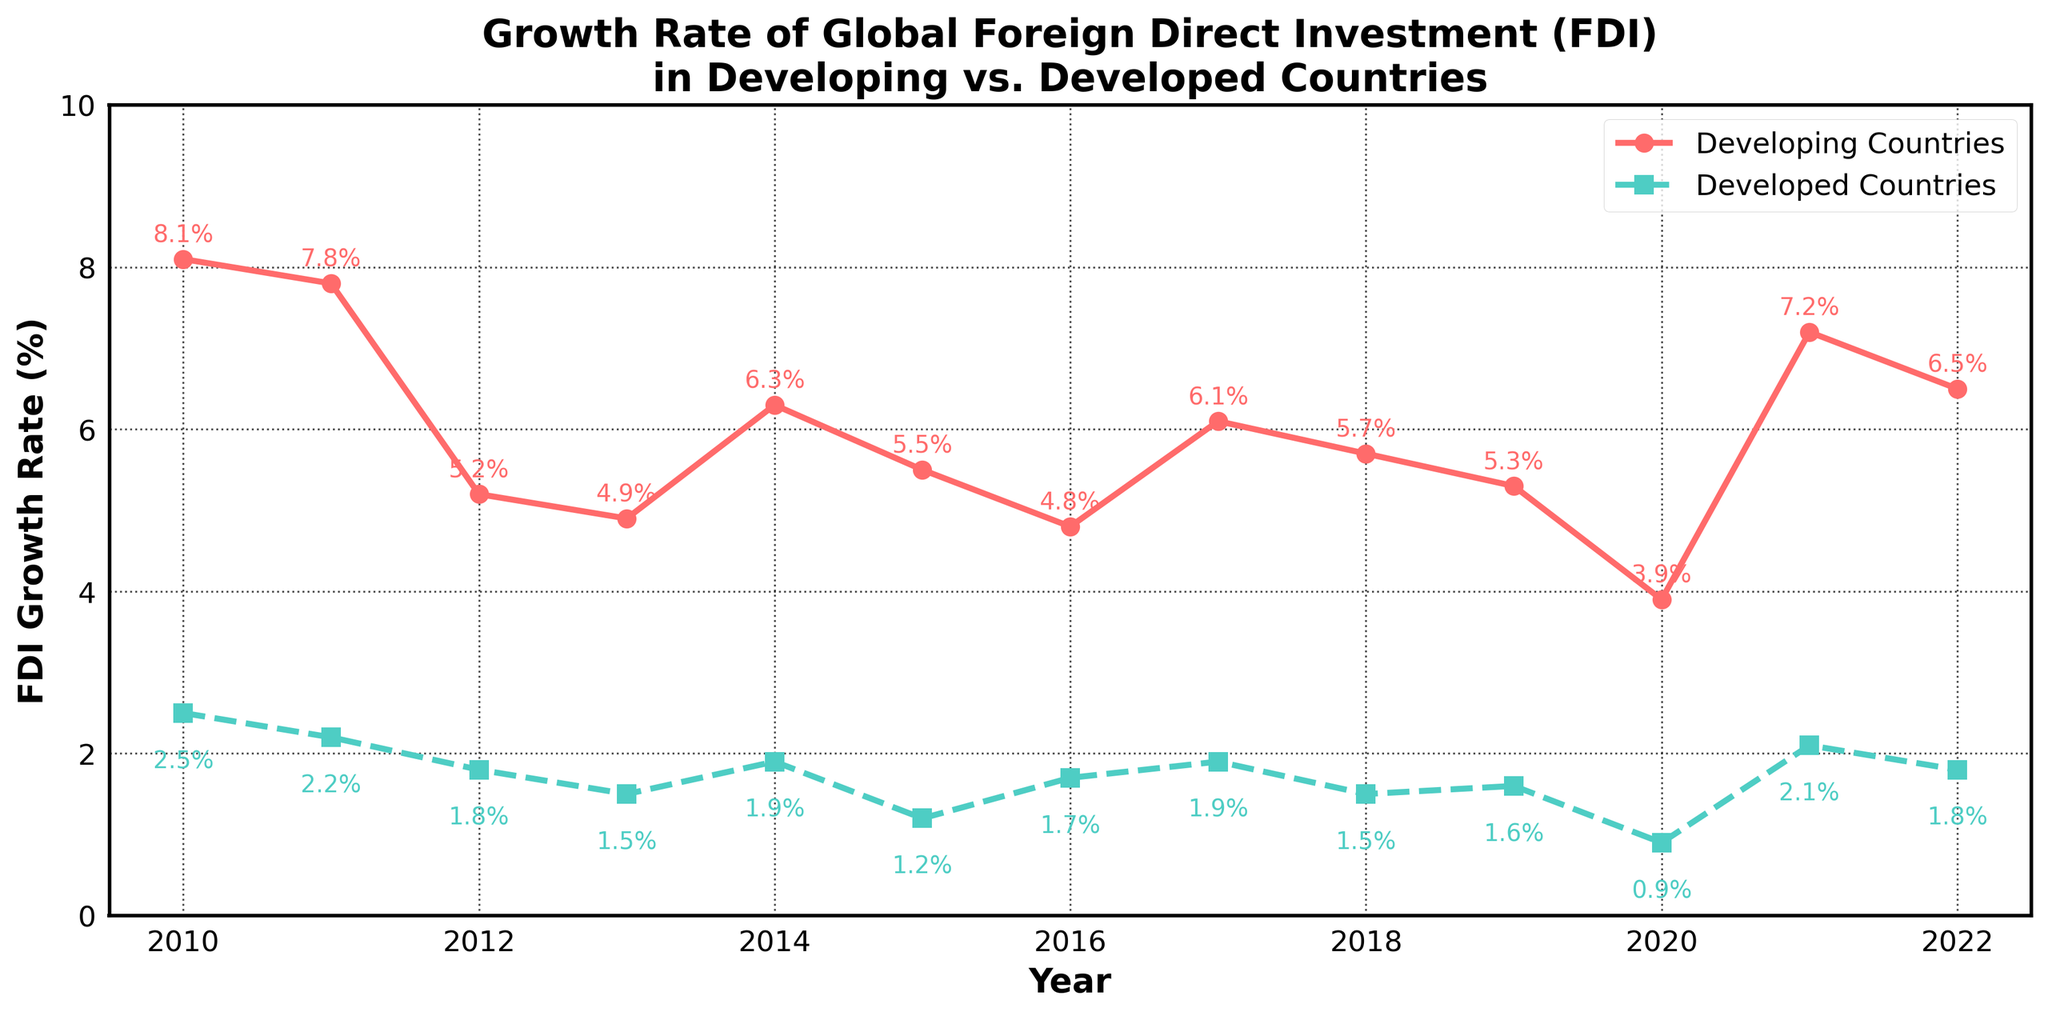What is the title of the figure? The title is shown at the top of the figure in bold. It reads "Growth Rate of Global Foreign Direct Investment (FDI) in Developing vs. Developed Countries."
Answer: Growth Rate of Global Foreign Direct Investment (FDI) in Developing vs. Developed Countries How many years of data are displayed in the figure? The x-axis labels indicate the year range from 2010 to 2022. Counting these labels gives us 13 years.
Answer: 13 years What’s the highest FDI growth rate recorded for developed countries, and in which year? The highest growth rate for developed countries is marked with the data point '2.5%' for the year 2010. This can be seen by identifying the highest point on the dashed line representing developed countries.
Answer: 2.5%, 2010 How does the growth rate for developing countries in 2022 compare to 2021? In 2021, the growth rate is 7.2%, and in 2022 it is 6.5%. Subtracting the 2022 value from the 2021 value indicates a decrease of 0.7%.
Answer: It decreased by 0.7% What's the lowest FDI growth rate recorded for developing countries, and in which year? The lowest growth rate for developing countries is marked with the data point '3.9%' for the year 2020. This can be seen by identifying the lowest point on the solid line representing developing countries.
Answer: 3.9%, 2020 In which year did developing countries experience their highest FDI growth rate, and what was it? The highest growth rate for developing countries is seen at 8.1% for the year 2010. This is the peak value on the solid line.
Answer: 8.1%, 2010 Compare the FDI growth rates for developed and developing countries in 2015. In 2015, the FDI growth rate for developing countries is 5.5%, while for developed countries it is 1.2%. To compare, 5.5% is higher than 1.2%.
Answer: Developing countries (5.5%) > Developed countries (1.2%) What is the average FDI growth rate for developed countries over the given period? To find the average, sum all the growth rates for developed countries (2.5 + 2.2 + 1.8 + 1.5 + 1.9 + 1.2 + 1.7 + 1.9 + 1.5 + 1.6 + 0.9 + 2.1 + 1.8), which is 22.6, and divide by the number of data points, 13. The average is 22.6/13 ≈ 1.74%.
Answer: ≈ 1.74% How did the FDI growth rate trend for developed countries change from 2010 to 2016? By observing the dashed line from 2010 to 2016, the growth rate generally shows a downward trend, starting at 2.5% in 2010 and reaching a lower point of 1.2% in 2015, before slightly increasing to 1.7% in 2016.
Answer: Downward trend In which years did both developing and developed countries experience an increase in FDI growth rate compared to the previous year? Analyzing the lines and labels, both developing and developed countries had increases in FDI growth rates from 2012 to 2013 (Developing: 5.2% to 4.9%, Developed: 1.5% to 1.7%), as well as from 2016 to 2017 (Developing: 4.8% to 6.1%, Developed: 1.7% to 1.9%).
Answer: 2013, 2017 